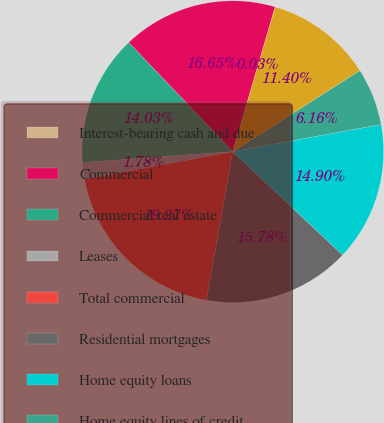<chart> <loc_0><loc_0><loc_500><loc_500><pie_chart><fcel>Interest-bearing cash and due<fcel>Commercial<fcel>Commercial real estate<fcel>Leases<fcel>Total commercial<fcel>Residential mortgages<fcel>Home equity loans<fcel>Home equity lines of credit<fcel>Home equity loans serviced by<nl><fcel>0.03%<fcel>16.65%<fcel>14.03%<fcel>1.78%<fcel>19.27%<fcel>15.78%<fcel>14.9%<fcel>6.16%<fcel>11.4%<nl></chart> 